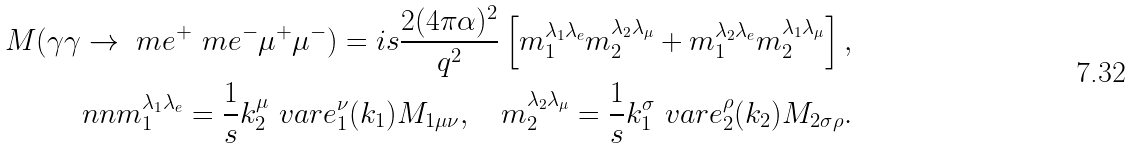Convert formula to latex. <formula><loc_0><loc_0><loc_500><loc_500>M ( \gamma \gamma \rightarrow \ m { e } ^ { + } \ m { e } ^ { - } \mu ^ { + } \mu ^ { - } ) = i s \frac { 2 ( 4 \pi \alpha ) ^ { 2 } } { q ^ { 2 } } \left [ m _ { 1 } ^ { \lambda _ { 1 } \lambda _ { e } } m _ { 2 } ^ { \lambda _ { 2 } \lambda _ { \mu } } + m _ { 1 } ^ { \lambda _ { 2 } \lambda _ { e } } m _ { 2 } ^ { \lambda _ { 1 } \lambda _ { \mu } } \right ] , \\ \ n n m _ { 1 } ^ { \lambda _ { 1 } \lambda _ { e } } = \frac { 1 } { s } k _ { 2 } ^ { \mu } \ v a r e _ { 1 } ^ { \nu } ( k _ { 1 } ) M _ { 1 \mu \nu } , \quad m _ { 2 } ^ { \lambda _ { 2 } \lambda _ { \mu } } = \frac { 1 } { s } k _ { 1 } ^ { \sigma } \ v a r e _ { 2 } ^ { \rho } ( k _ { 2 } ) M _ { 2 \sigma \rho } .</formula> 